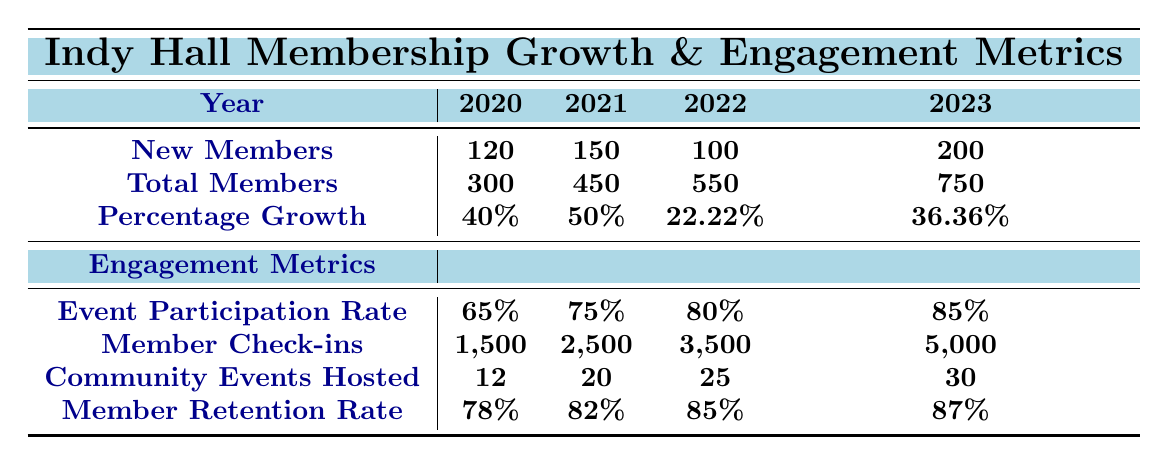How many new members joined Indy Hall in 2021? The table shows that in 2021, the number of new members is listed as 150.
Answer: 150 What was the total number of members at Indy Hall in 2022? According to the table, the total number of members in 2022 is stated as 550.
Answer: 550 What is the percentage growth of memberships from 2020 to 2021? The percentage growth from 2020 (40%) to 2021 (50%) is calculated as follows: The value increased by 10%. Therefore, it is simply the difference between the two years.
Answer: 10% What is the total number of members over the four years? To find the total number of members over the years (2020-2023), we sum the total members: 300 + 450 + 550 + 750 = 2050.
Answer: 2050 How many community events were hosted in 2023 compared to 2020? The number of community events hosted in 2023 is 30, while in 2020 it was 12. The difference is calculated as 30 - 12 = 18.
Answer: 18 What was the average event participation rate over the four years? To find the average event participation rate, we add the rates: (65% + 75% + 80% + 85%) / 4 = 76.25%.
Answer: 76.25% Based on the data, did the member retention rate increase every year? The retention rate percentages are 78% in 2020, 82% in 2021, 85% in 2022, and 87% in 2023. Since all values increased each year, the answer is yes.
Answer: Yes What was the total member check-ins in 2023 and how does it compare to 2020? The member check-ins in 2023 are 5,000 and in 2020 were 1,500. The increase is found by subtracting 1,500 from 5,000, resulting in an increase of 3,500.
Answer: 3,500 What was the growth rate in memberships from 2021 to 2022? The percentage growth from 2021 (50%) to 2022 (22.22%) is negative, showing a decline in growth rate. The difference is calculated as 50% - 22.22% = 27.78%.
Answer: 27.78% decline How many new members joined between 2020 and 2023 combined? The total new members are calculated by summing: 120 (2020) + 150 (2021) + 100 (2022) + 200 (2023) = 570.
Answer: 570 